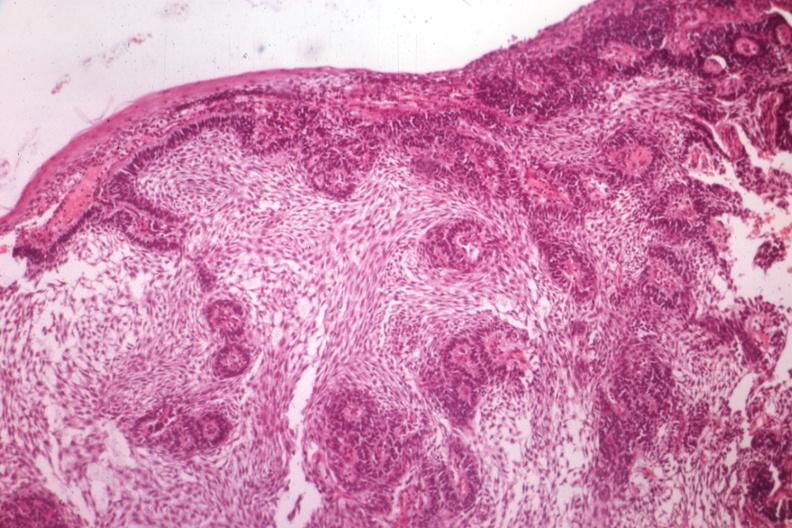what is the unknown origin in mandible?
Answer the question using a single word or phrase. A guess 